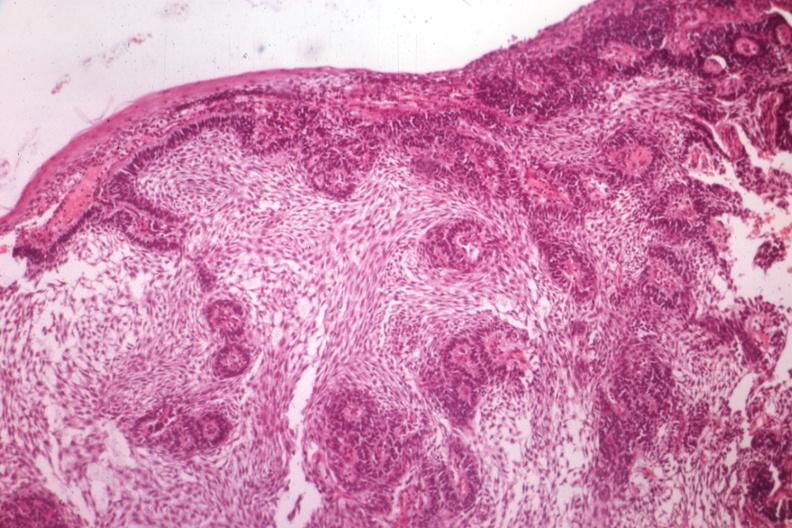what is the unknown origin in mandible?
Answer the question using a single word or phrase. A guess 